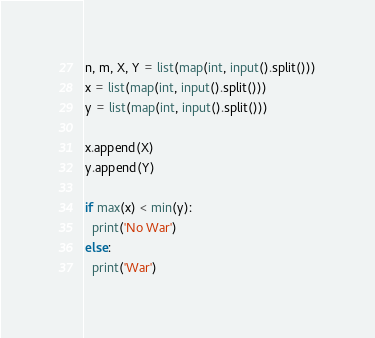Convert code to text. <code><loc_0><loc_0><loc_500><loc_500><_Python_>n, m, X, Y = list(map(int, input().split()))
x = list(map(int, input().split()))
y = list(map(int, input().split()))

x.append(X)
y.append(Y)

if max(x) < min(y):
  print('No War')
else:
  print('War')
</code> 